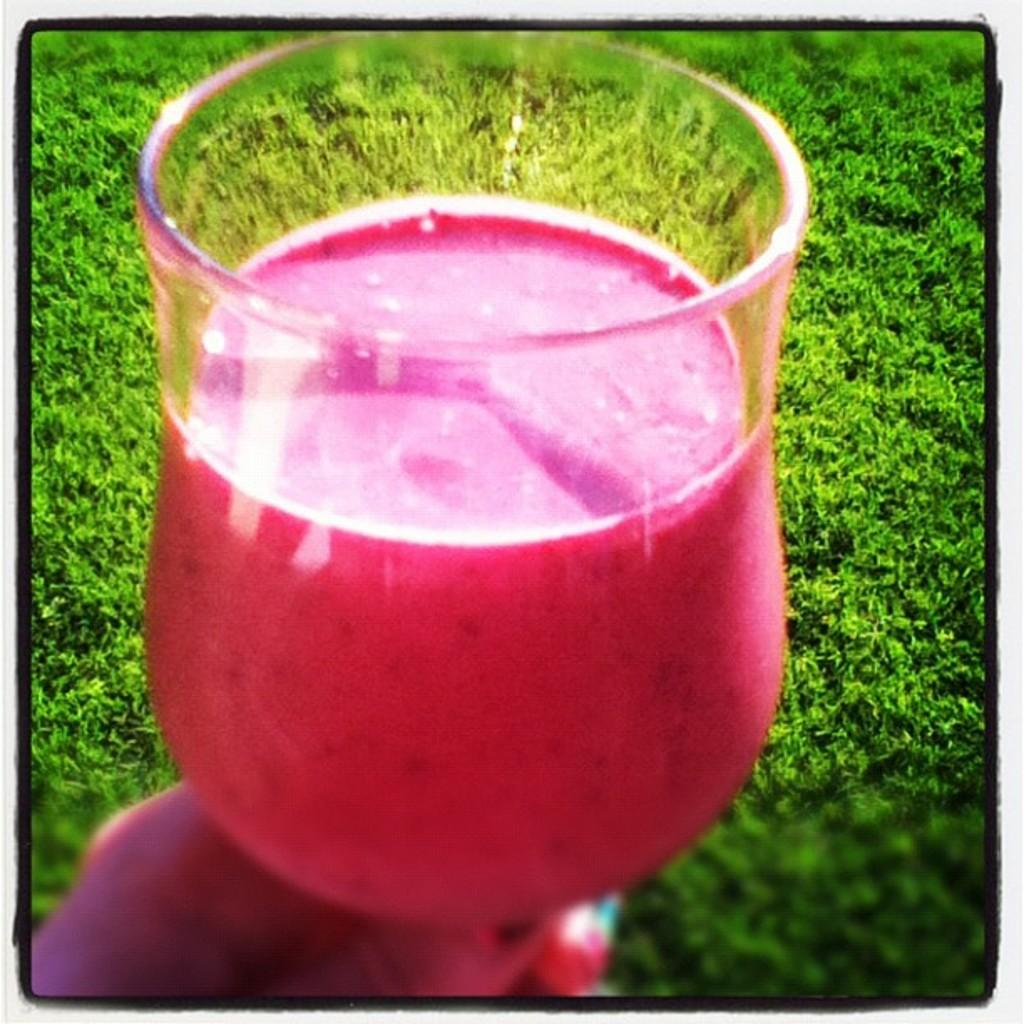What is the person holding in the image? There is a person's hand holding a glass in the image. What is inside the glass? The glass contains a drink. What can be seen in the background of the image? There is grass visible in the background of the image. How many friends is the queen inviting to her pin ceremony in the image? There is no reference to a queen, friends, or pin ceremony in the image; it only shows a person's hand holding a glass with a drink. 